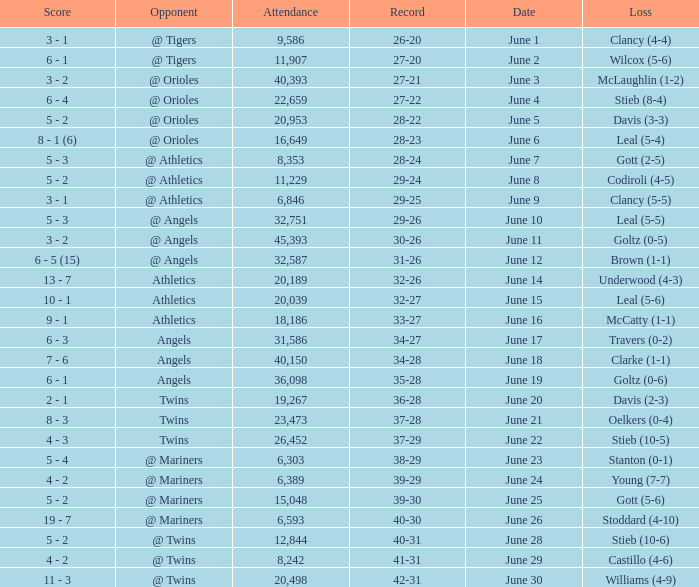What was the record where the opponent was @ Orioles and the loss was to Leal (5-4)? 28-23. 